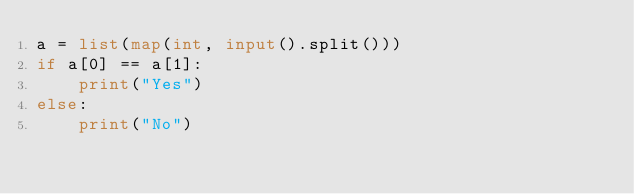Convert code to text. <code><loc_0><loc_0><loc_500><loc_500><_Python_>a = list(map(int, input().split()))
if a[0] == a[1]:
    print("Yes")
else:
    print("No")</code> 